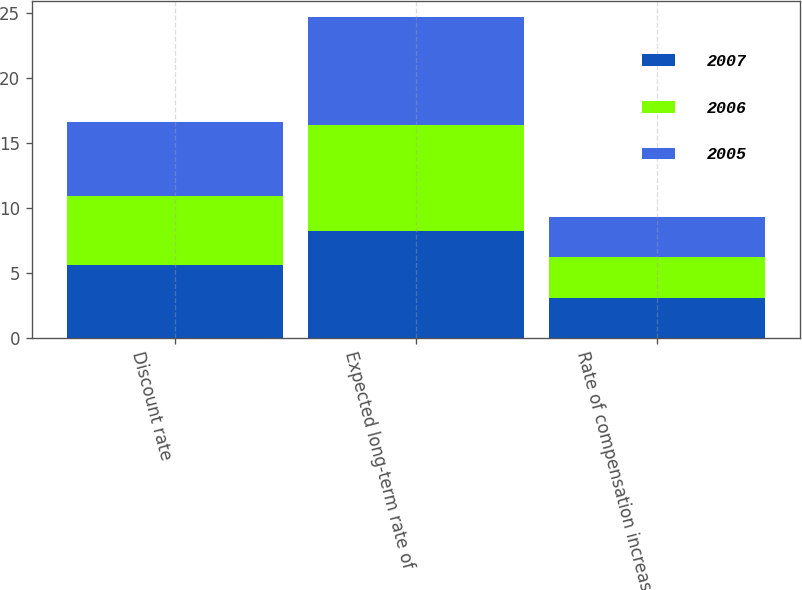Convert chart to OTSL. <chart><loc_0><loc_0><loc_500><loc_500><stacked_bar_chart><ecel><fcel>Discount rate<fcel>Expected long-term rate of<fcel>Rate of compensation increase<nl><fcel>2007<fcel>5.6<fcel>8.2<fcel>3.1<nl><fcel>2006<fcel>5.3<fcel>8.2<fcel>3.1<nl><fcel>2005<fcel>5.7<fcel>8.3<fcel>3.1<nl></chart> 